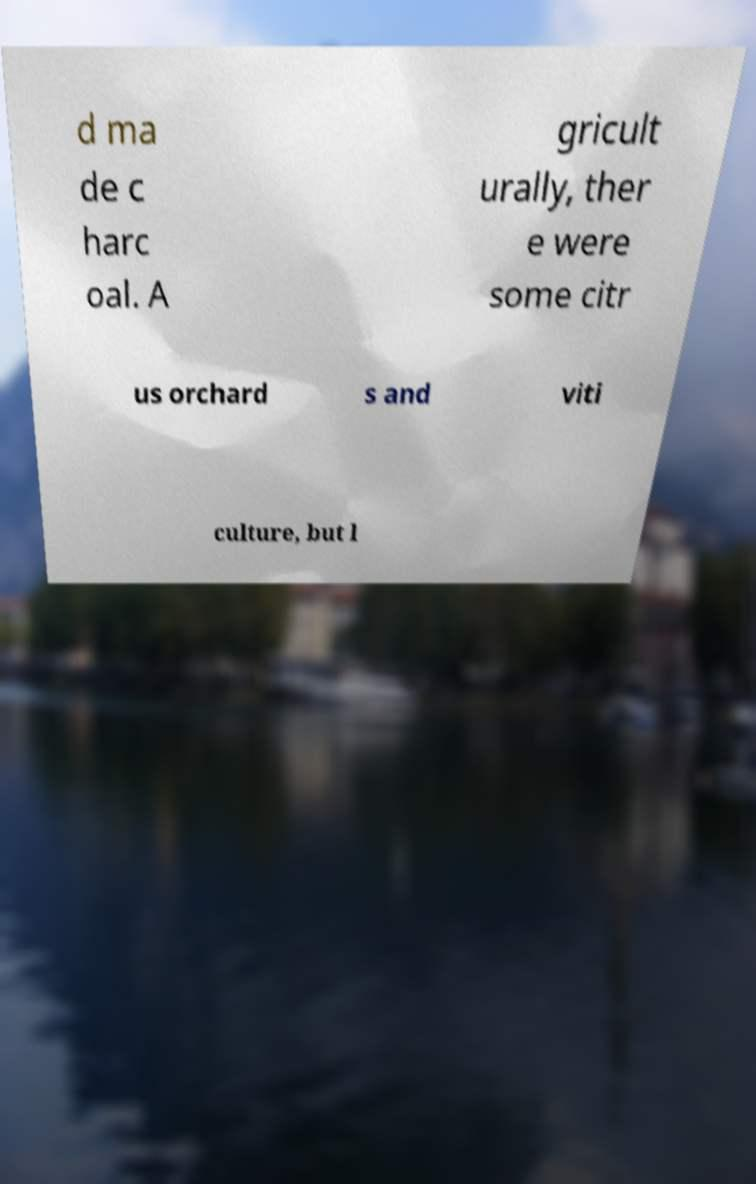For documentation purposes, I need the text within this image transcribed. Could you provide that? d ma de c harc oal. A gricult urally, ther e were some citr us orchard s and viti culture, but l 